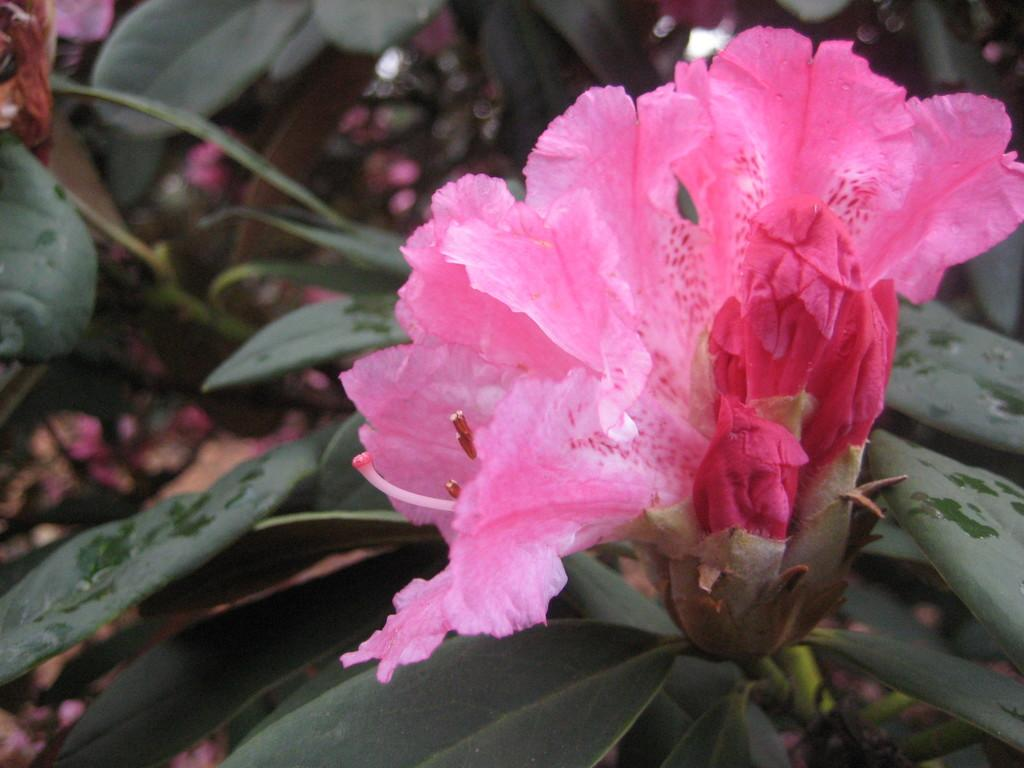What is the main subject of the picture? There is a pin color flower in the middle of the picture. What can be seen in the background of the picture? There are plants in the background of the picture. How many cherries are hanging from the branches of the deer in the image? There is no deer or cherries present in the image; it features a pin color flower and plants in the background. 